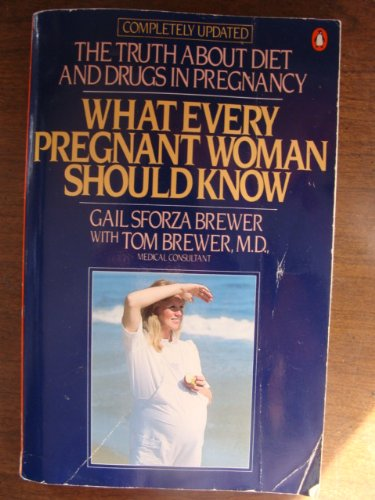What is the title of this book? The title of the book is 'What Every Pregnant Woman Should Know,' which provides insights into diet and medical care during pregnancy. 